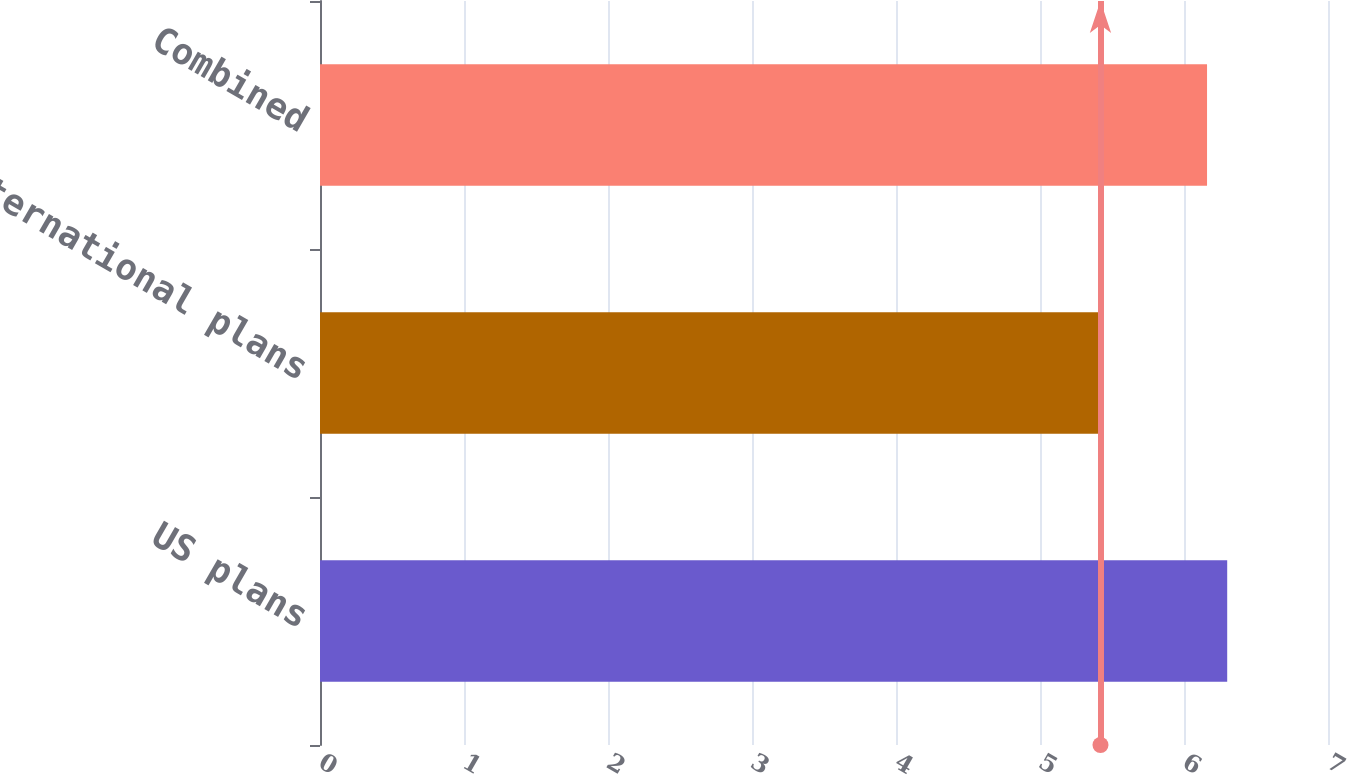Convert chart to OTSL. <chart><loc_0><loc_0><loc_500><loc_500><bar_chart><fcel>US plans<fcel>International plans<fcel>Combined<nl><fcel>6.3<fcel>5.42<fcel>6.16<nl></chart> 